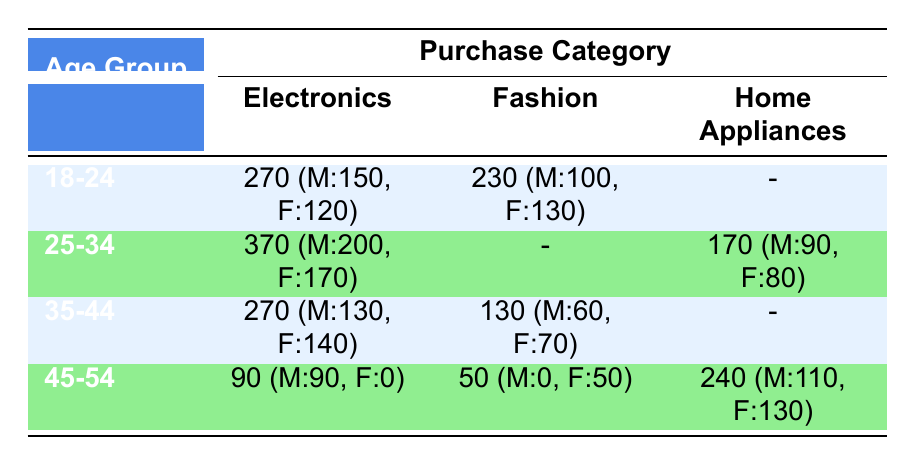What is the total number of Electronics purchases made by the 18-24 age group? The total number of Electronics purchases by the 18-24 age group is given directly in the table, which states 270 (150 males and 120 females).
Answer: 270 How many Fashion purchases were made by females in the 25-34 age group? There are no Fashion purchases listed for the 25-34 age group in the table, hence the count is zero.
Answer: 0 What is the total number of Home Appliances purchases across all age groups? The total number of Home Appliances purchases is 170 (from 25-34 age group) + 240 (from 45-54 age group) = 410.
Answer: 410 Did more males or females purchase Electronics in the 35-44 age group? The count of purchases is 130 for males and 140 for females in the Electronics category for the 35-44 age group. Since 140 is greater than 130, more females purchased Electronics.
Answer: Yes What percentage of the 45-54 age group's purchases were Fashion purchases? The total purchases in the 45-54 age group are 90 (Home Appliances) + 50 (Fashion) + 0 (Electronics) = 140. The Fashion purchases are 50, so the percentage is (50/140) * 100, which simplifies to approximately 35.71%.
Answer: 35.71% 